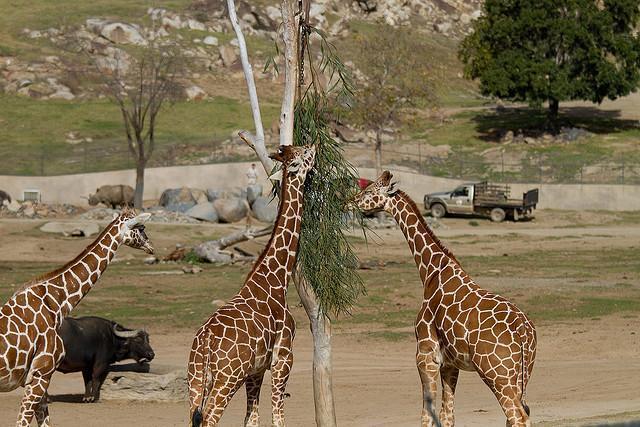How many giraffes are visible?
Give a very brief answer. 3. How many white computer mice are in the image?
Give a very brief answer. 0. 